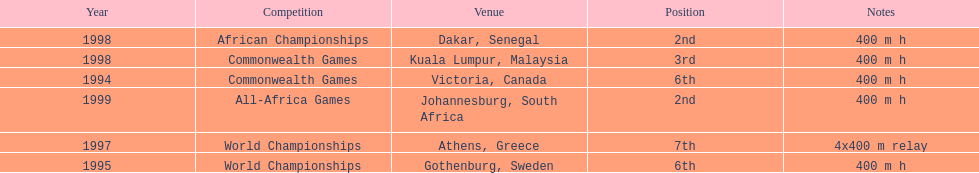What was the venue before dakar, senegal? Kuala Lumpur, Malaysia. 